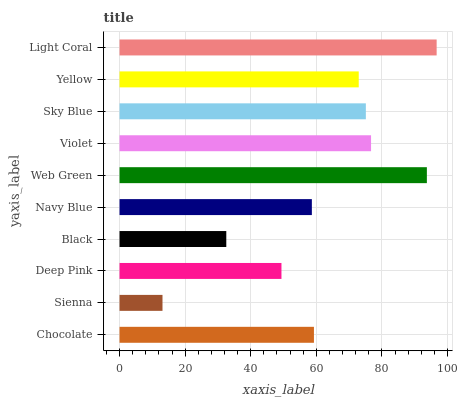Is Sienna the minimum?
Answer yes or no. Yes. Is Light Coral the maximum?
Answer yes or no. Yes. Is Deep Pink the minimum?
Answer yes or no. No. Is Deep Pink the maximum?
Answer yes or no. No. Is Deep Pink greater than Sienna?
Answer yes or no. Yes. Is Sienna less than Deep Pink?
Answer yes or no. Yes. Is Sienna greater than Deep Pink?
Answer yes or no. No. Is Deep Pink less than Sienna?
Answer yes or no. No. Is Yellow the high median?
Answer yes or no. Yes. Is Chocolate the low median?
Answer yes or no. Yes. Is Navy Blue the high median?
Answer yes or no. No. Is Black the low median?
Answer yes or no. No. 